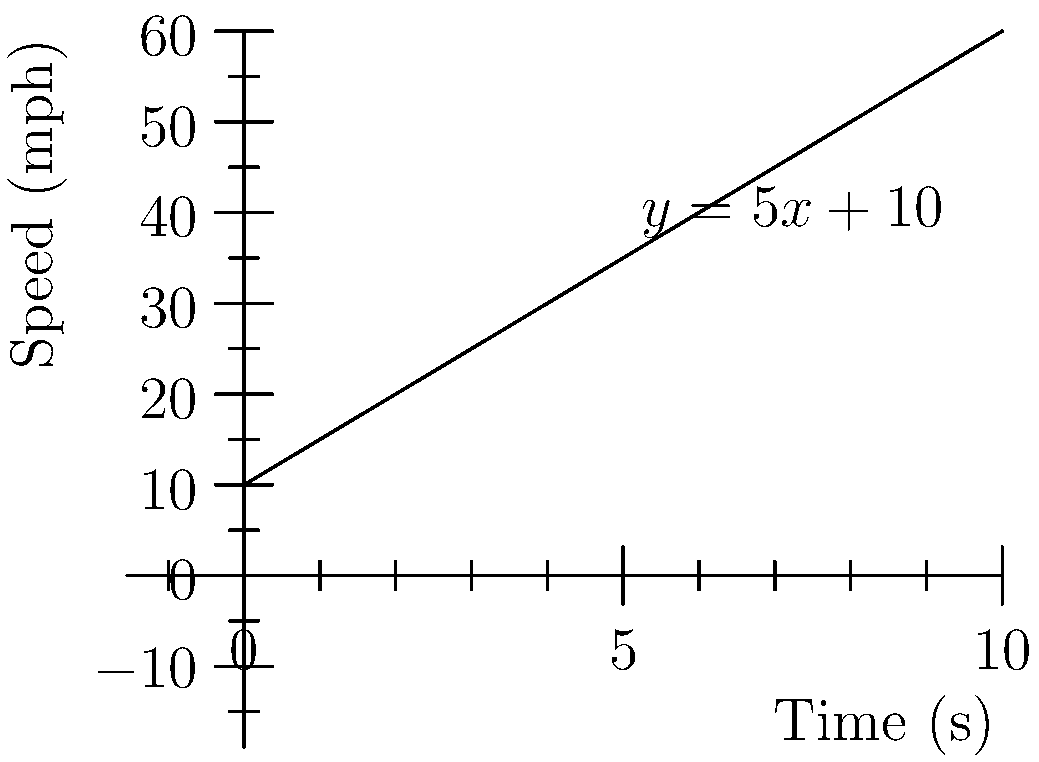At a classic car rally, your 1967 Mustang's speed is being monitored. The graph shows the car's speed (in mph) over time (in seconds). If the initial speed was 10 mph and the acceleration remained constant, what is the equation of the line representing the car's speed over time? To find the equation of the line, we'll use the point-slope form: $y - y_1 = m(x - x_1)$

1. Identify the initial point: $(0, 10)$
   This represents the initial speed of 10 mph at 0 seconds.

2. Calculate the slope (m):
   The slope represents the acceleration, which is the change in speed over time.
   We can pick any other point on the line, let's use $(10, 60)$
   $m = \frac{y_2 - y_1}{x_2 - x_1} = \frac{60 - 10}{10 - 0} = \frac{50}{10} = 5$

3. Use the point-slope form:
   $y - 10 = 5(x - 0)$

4. Simplify:
   $y - 10 = 5x$
   $y = 5x + 10$

This equation, $y = 5x + 10$, represents the speed (y) of the car at any given time (x).
Answer: $y = 5x + 10$ 